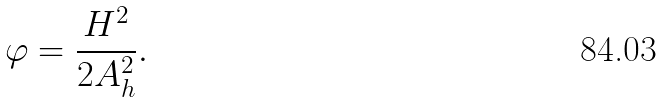<formula> <loc_0><loc_0><loc_500><loc_500>\varphi = \frac { H ^ { 2 } } { 2 A _ { h } ^ { 2 } } .</formula> 